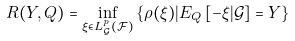<formula> <loc_0><loc_0><loc_500><loc_500>R ( Y , Q ) = \inf _ { \xi \in L _ { \mathcal { G } } ^ { p } ( \mathcal { F } ) } \left \{ \rho ( \xi ) | E _ { Q } \left [ - \xi | \mathcal { G } \right ] = Y \right \}</formula> 